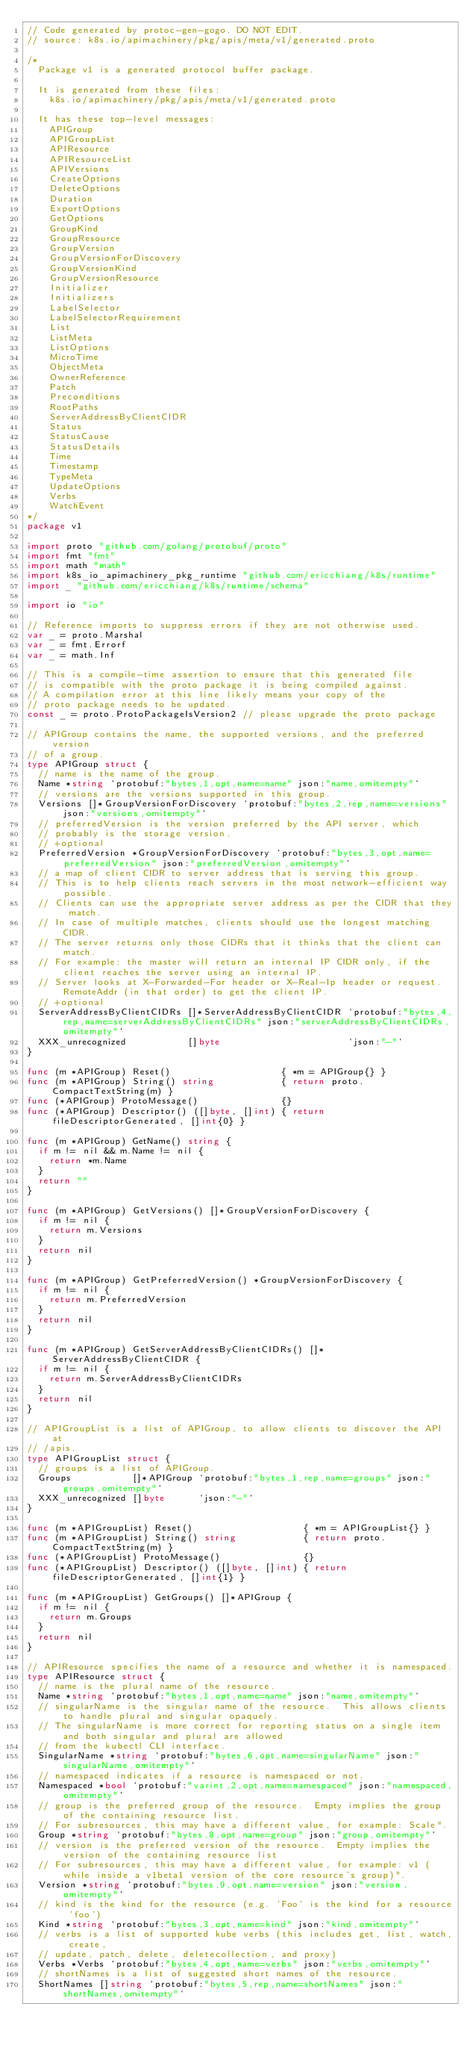Convert code to text. <code><loc_0><loc_0><loc_500><loc_500><_Go_>// Code generated by protoc-gen-gogo. DO NOT EDIT.
// source: k8s.io/apimachinery/pkg/apis/meta/v1/generated.proto

/*
	Package v1 is a generated protocol buffer package.

	It is generated from these files:
		k8s.io/apimachinery/pkg/apis/meta/v1/generated.proto

	It has these top-level messages:
		APIGroup
		APIGroupList
		APIResource
		APIResourceList
		APIVersions
		CreateOptions
		DeleteOptions
		Duration
		ExportOptions
		GetOptions
		GroupKind
		GroupResource
		GroupVersion
		GroupVersionForDiscovery
		GroupVersionKind
		GroupVersionResource
		Initializer
		Initializers
		LabelSelector
		LabelSelectorRequirement
		List
		ListMeta
		ListOptions
		MicroTime
		ObjectMeta
		OwnerReference
		Patch
		Preconditions
		RootPaths
		ServerAddressByClientCIDR
		Status
		StatusCause
		StatusDetails
		Time
		Timestamp
		TypeMeta
		UpdateOptions
		Verbs
		WatchEvent
*/
package v1

import proto "github.com/golang/protobuf/proto"
import fmt "fmt"
import math "math"
import k8s_io_apimachinery_pkg_runtime "github.com/ericchiang/k8s/runtime"
import _ "github.com/ericchiang/k8s/runtime/schema"

import io "io"

// Reference imports to suppress errors if they are not otherwise used.
var _ = proto.Marshal
var _ = fmt.Errorf
var _ = math.Inf

// This is a compile-time assertion to ensure that this generated file
// is compatible with the proto package it is being compiled against.
// A compilation error at this line likely means your copy of the
// proto package needs to be updated.
const _ = proto.ProtoPackageIsVersion2 // please upgrade the proto package

// APIGroup contains the name, the supported versions, and the preferred version
// of a group.
type APIGroup struct {
	// name is the name of the group.
	Name *string `protobuf:"bytes,1,opt,name=name" json:"name,omitempty"`
	// versions are the versions supported in this group.
	Versions []*GroupVersionForDiscovery `protobuf:"bytes,2,rep,name=versions" json:"versions,omitempty"`
	// preferredVersion is the version preferred by the API server, which
	// probably is the storage version.
	// +optional
	PreferredVersion *GroupVersionForDiscovery `protobuf:"bytes,3,opt,name=preferredVersion" json:"preferredVersion,omitempty"`
	// a map of client CIDR to server address that is serving this group.
	// This is to help clients reach servers in the most network-efficient way possible.
	// Clients can use the appropriate server address as per the CIDR that they match.
	// In case of multiple matches, clients should use the longest matching CIDR.
	// The server returns only those CIDRs that it thinks that the client can match.
	// For example: the master will return an internal IP CIDR only, if the client reaches the server using an internal IP.
	// Server looks at X-Forwarded-For header or X-Real-Ip header or request.RemoteAddr (in that order) to get the client IP.
	// +optional
	ServerAddressByClientCIDRs []*ServerAddressByClientCIDR `protobuf:"bytes,4,rep,name=serverAddressByClientCIDRs" json:"serverAddressByClientCIDRs,omitempty"`
	XXX_unrecognized           []byte                       `json:"-"`
}

func (m *APIGroup) Reset()                    { *m = APIGroup{} }
func (m *APIGroup) String() string            { return proto.CompactTextString(m) }
func (*APIGroup) ProtoMessage()               {}
func (*APIGroup) Descriptor() ([]byte, []int) { return fileDescriptorGenerated, []int{0} }

func (m *APIGroup) GetName() string {
	if m != nil && m.Name != nil {
		return *m.Name
	}
	return ""
}

func (m *APIGroup) GetVersions() []*GroupVersionForDiscovery {
	if m != nil {
		return m.Versions
	}
	return nil
}

func (m *APIGroup) GetPreferredVersion() *GroupVersionForDiscovery {
	if m != nil {
		return m.PreferredVersion
	}
	return nil
}

func (m *APIGroup) GetServerAddressByClientCIDRs() []*ServerAddressByClientCIDR {
	if m != nil {
		return m.ServerAddressByClientCIDRs
	}
	return nil
}

// APIGroupList is a list of APIGroup, to allow clients to discover the API at
// /apis.
type APIGroupList struct {
	// groups is a list of APIGroup.
	Groups           []*APIGroup `protobuf:"bytes,1,rep,name=groups" json:"groups,omitempty"`
	XXX_unrecognized []byte      `json:"-"`
}

func (m *APIGroupList) Reset()                    { *m = APIGroupList{} }
func (m *APIGroupList) String() string            { return proto.CompactTextString(m) }
func (*APIGroupList) ProtoMessage()               {}
func (*APIGroupList) Descriptor() ([]byte, []int) { return fileDescriptorGenerated, []int{1} }

func (m *APIGroupList) GetGroups() []*APIGroup {
	if m != nil {
		return m.Groups
	}
	return nil
}

// APIResource specifies the name of a resource and whether it is namespaced.
type APIResource struct {
	// name is the plural name of the resource.
	Name *string `protobuf:"bytes,1,opt,name=name" json:"name,omitempty"`
	// singularName is the singular name of the resource.  This allows clients to handle plural and singular opaquely.
	// The singularName is more correct for reporting status on a single item and both singular and plural are allowed
	// from the kubectl CLI interface.
	SingularName *string `protobuf:"bytes,6,opt,name=singularName" json:"singularName,omitempty"`
	// namespaced indicates if a resource is namespaced or not.
	Namespaced *bool `protobuf:"varint,2,opt,name=namespaced" json:"namespaced,omitempty"`
	// group is the preferred group of the resource.  Empty implies the group of the containing resource list.
	// For subresources, this may have a different value, for example: Scale".
	Group *string `protobuf:"bytes,8,opt,name=group" json:"group,omitempty"`
	// version is the preferred version of the resource.  Empty implies the version of the containing resource list
	// For subresources, this may have a different value, for example: v1 (while inside a v1beta1 version of the core resource's group)".
	Version *string `protobuf:"bytes,9,opt,name=version" json:"version,omitempty"`
	// kind is the kind for the resource (e.g. 'Foo' is the kind for a resource 'foo')
	Kind *string `protobuf:"bytes,3,opt,name=kind" json:"kind,omitempty"`
	// verbs is a list of supported kube verbs (this includes get, list, watch, create,
	// update, patch, delete, deletecollection, and proxy)
	Verbs *Verbs `protobuf:"bytes,4,opt,name=verbs" json:"verbs,omitempty"`
	// shortNames is a list of suggested short names of the resource.
	ShortNames []string `protobuf:"bytes,5,rep,name=shortNames" json:"shortNames,omitempty"`</code> 